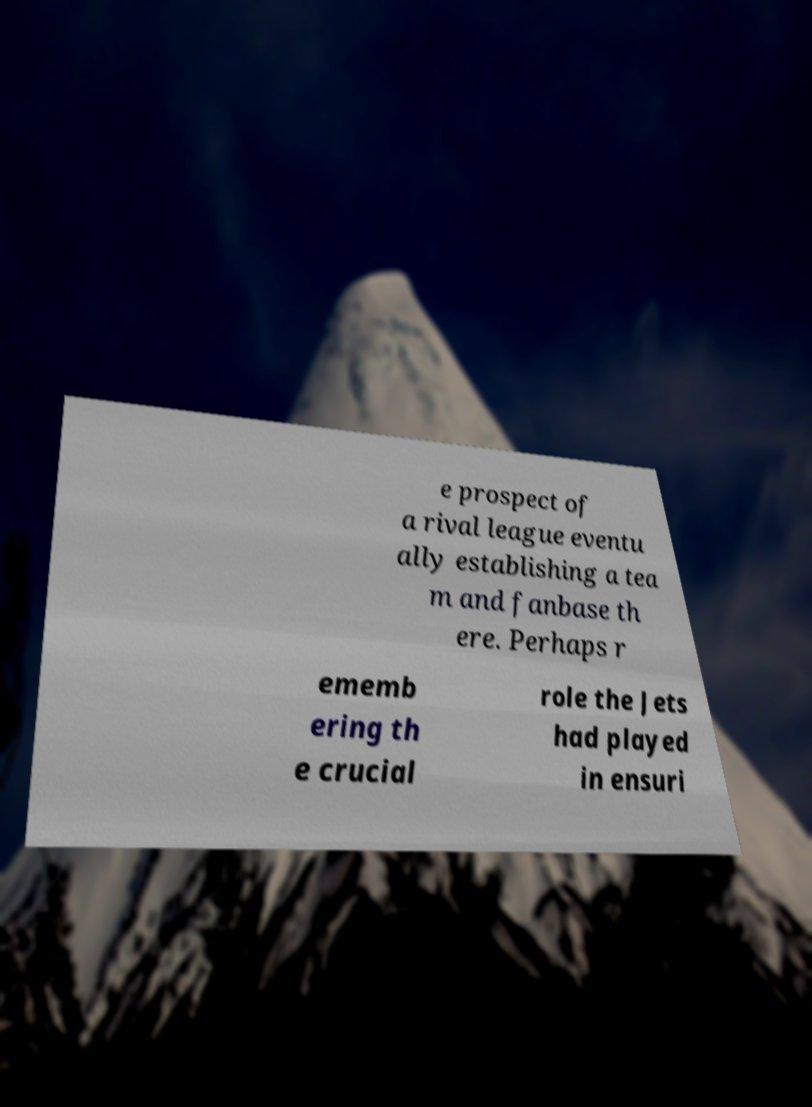Please read and relay the text visible in this image. What does it say? e prospect of a rival league eventu ally establishing a tea m and fanbase th ere. Perhaps r ememb ering th e crucial role the Jets had played in ensuri 